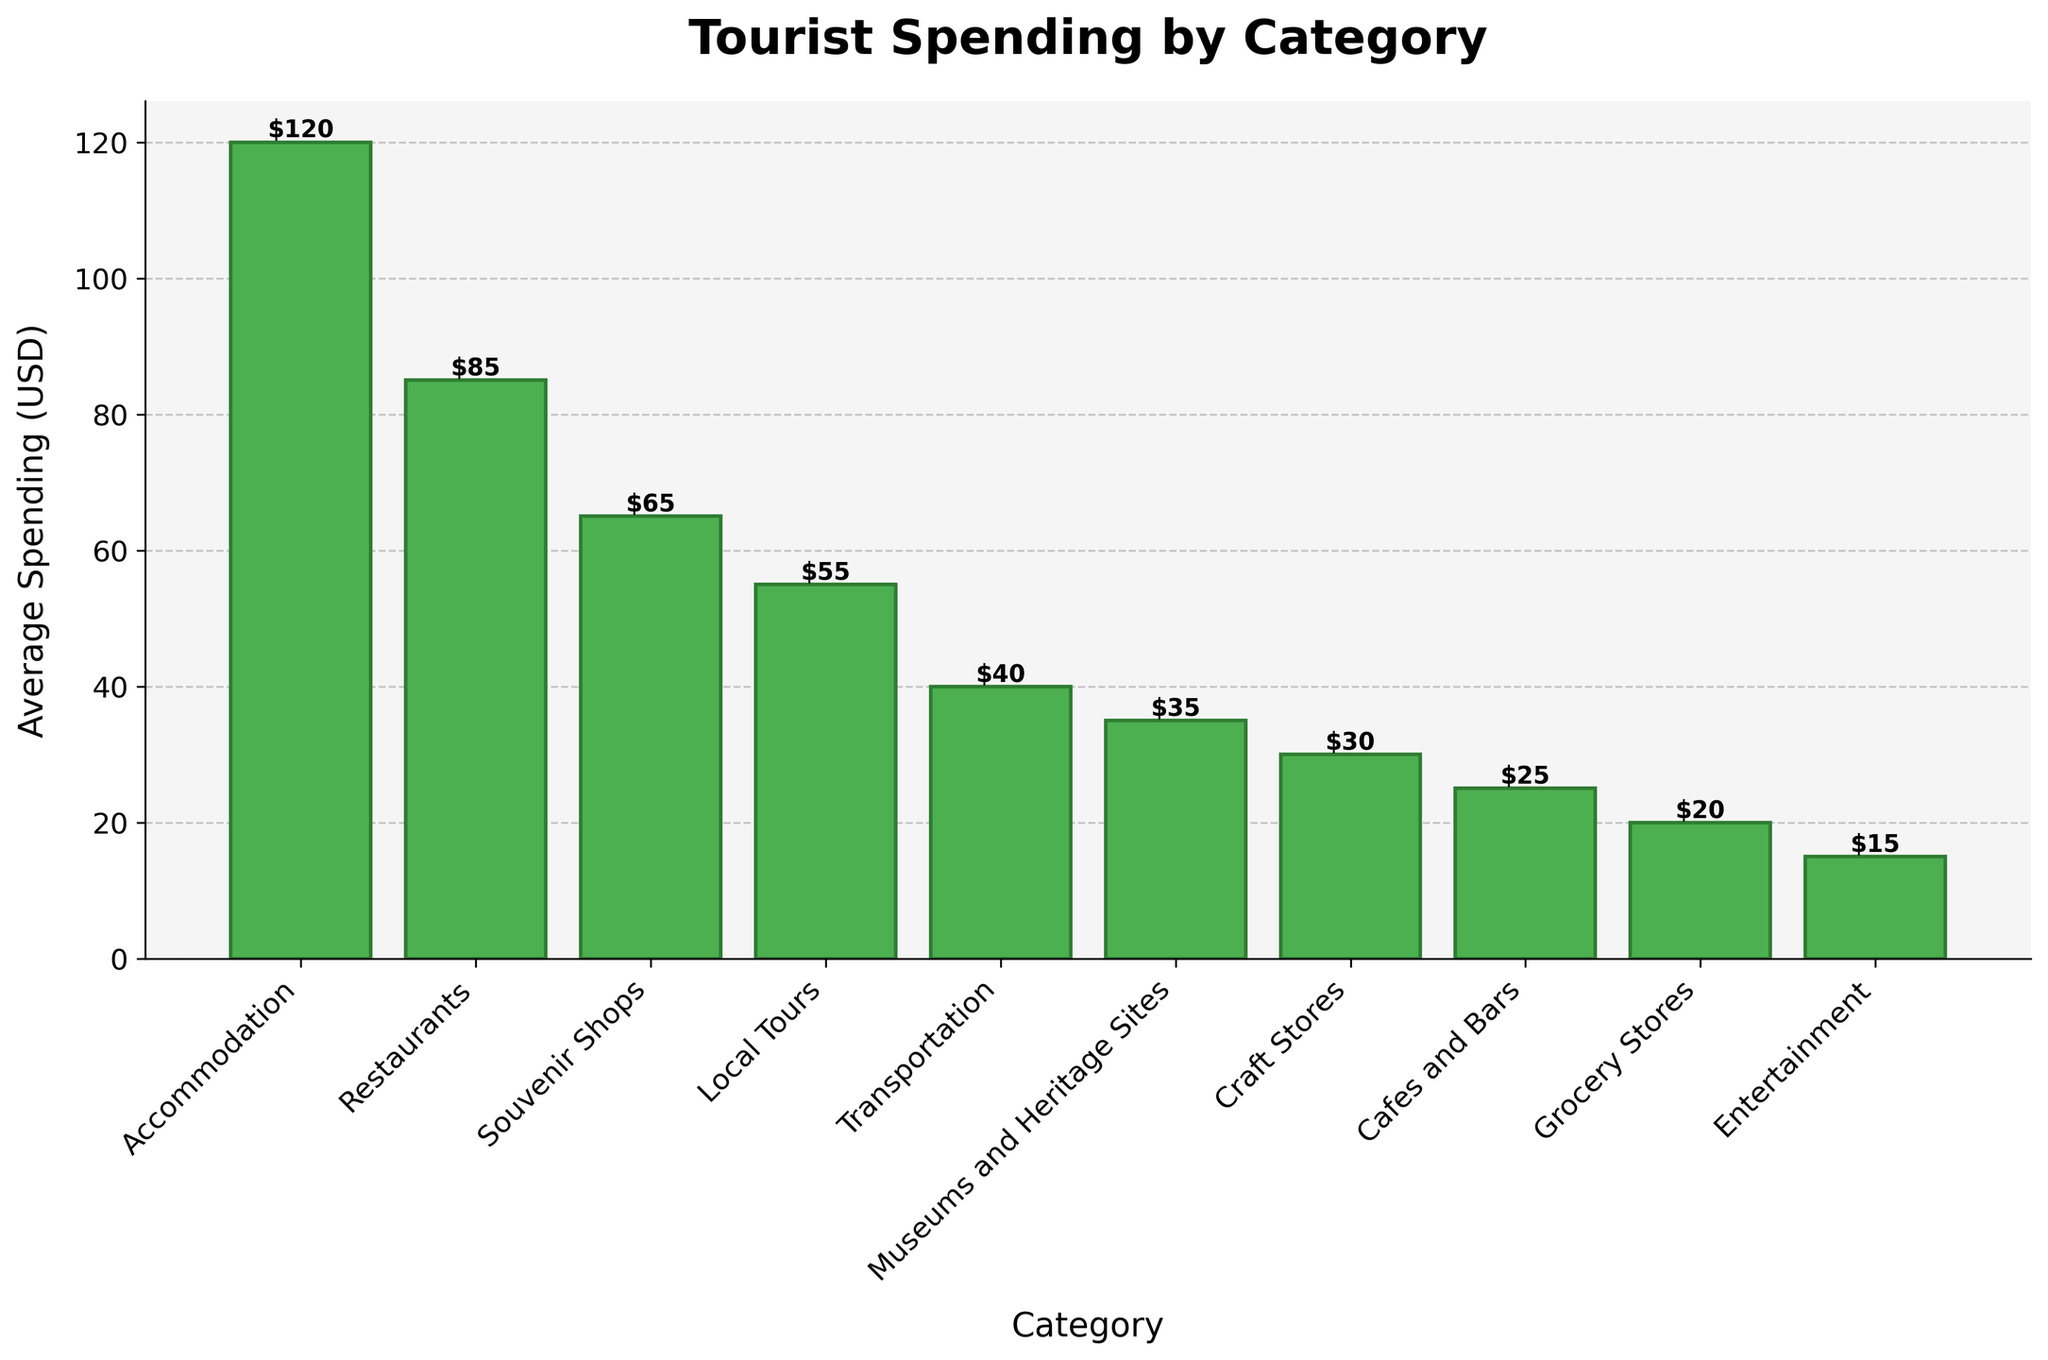Which category has the highest average spending? The highest average spending bar is for Accommodation, which reaches the highest point on the y-axis at $120.
Answer: Accommodation How much more do tourists spend on Restaurants compared to Local Tours on average? The average spending on Restaurants is $85, and the average spending on Local Tours is $55. The difference is $85 - $55.
Answer: $30 What is the combined average spending on Cafes and Bars and Grocery Stores? The average spending on Cafes and Bars is $25, and the average spending on Grocery Stores is $20. Summing them gives $25 + $20.
Answer: $45 Which category has the lowest average spending, and what is that amount? The bar for Entertainment is the shortest and reaches the lowest point on the y-axis at $15.
Answer: Entertainment, $15 Do tourists spend more on Transportation or Museums and Heritage Sites? The average spending on Transportation is $40, while the average spending on Museums and Heritage Sites is $35. Since $40 is greater than $35, tourists spend more on Transportation.
Answer: Transportation What is the average spending on Local Tours as a percentage of the average spending on Accommodation? The average spending on Local Tours is $55, and the average spending on Accommodation is $120. The percentage is ($55 / $120) * 100.
Answer: 45.83% What is the total average spending across all categories? Summing the average spendings across all categories: $120 + $85 + $65 + $55 + $40 + $35 + $30 + $25 + $20 + $15.
Answer: $490 Compare the combined average spending on Souvenir Shops and Craft Stores with that on Entertainment. Which is higher and by how much? The combined average spending on Souvenir Shops and Craft Stores is $65 + $30 = $95. The average spending on Entertainment is $15. The difference is $95 - $15.
Answer: Souvenir Shops and Craft Stores by $80 Are there more categories where average spending is below $40 or above $40? How many are there in each group? Categories below $40: Museums and Heritage Sites, Craft Stores, Cafes and Bars, Grocery Stores, Entertainment. (5 categories). Categories above $40: Accommodation, Restaurants, Souvenir Shops, Local Tours, Transportation. (5 categories). The numbers are equal.
Answer: Equal, 5 in each group What is the difference in average spending between the highest and lowest categories? The highest average spending is on Accommodation at $120 and the lowest is on Entertainment at $15. The difference is $120 - $15.
Answer: $105 